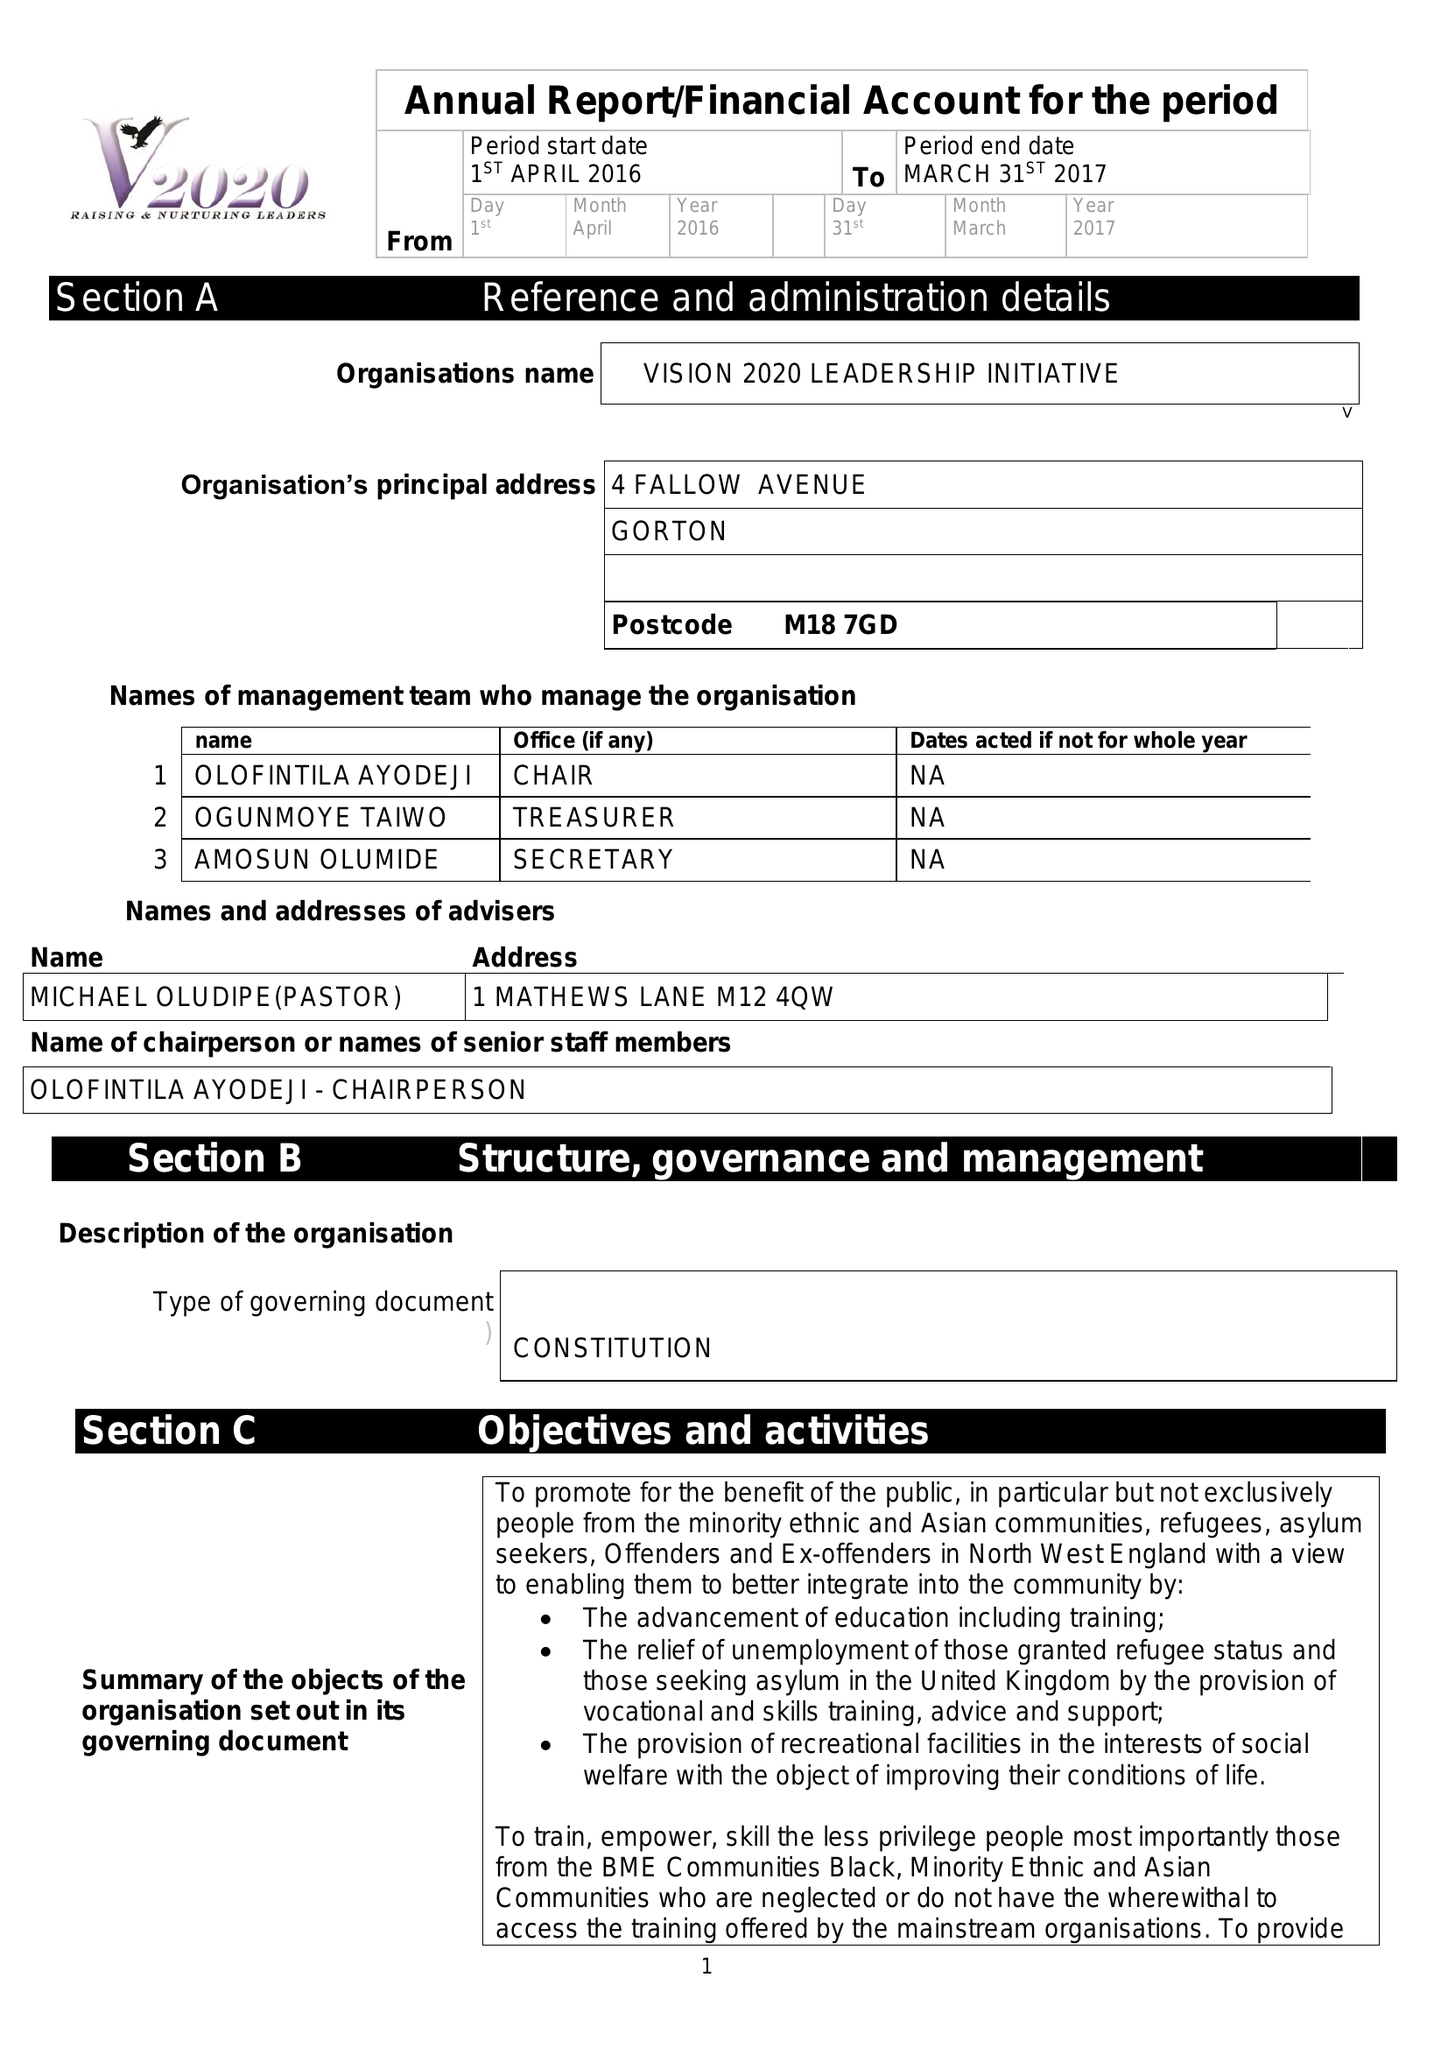What is the value for the address__postcode?
Answer the question using a single word or phrase. M18 7GD 